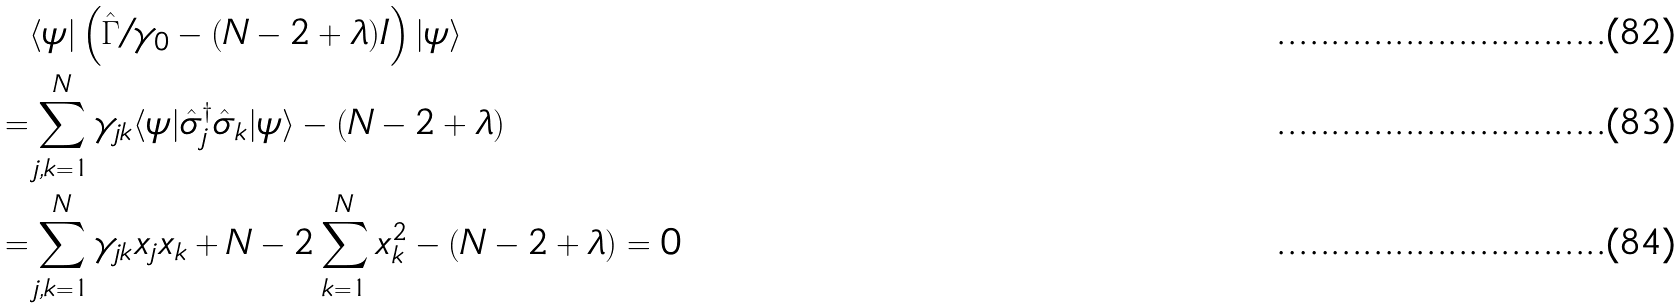Convert formula to latex. <formula><loc_0><loc_0><loc_500><loc_500>& \langle \psi | \left ( \hat { \Gamma } / \gamma _ { 0 } - ( N - 2 + \lambda ) I \right ) | \psi \rangle \\ = & \sum _ { j , k = 1 } ^ { N } \gamma _ { j k } \langle \psi | \hat { \sigma } _ { j } ^ { \dagger } \hat { \sigma } _ { k } | \psi \rangle - ( N - 2 + \lambda ) \\ = & \sum _ { j , k = 1 } ^ { N } \gamma _ { j k } x _ { j } x _ { k } + N - 2 \sum _ { k = 1 } ^ { N } x _ { k } ^ { 2 } - ( N - 2 + \lambda ) = 0</formula> 